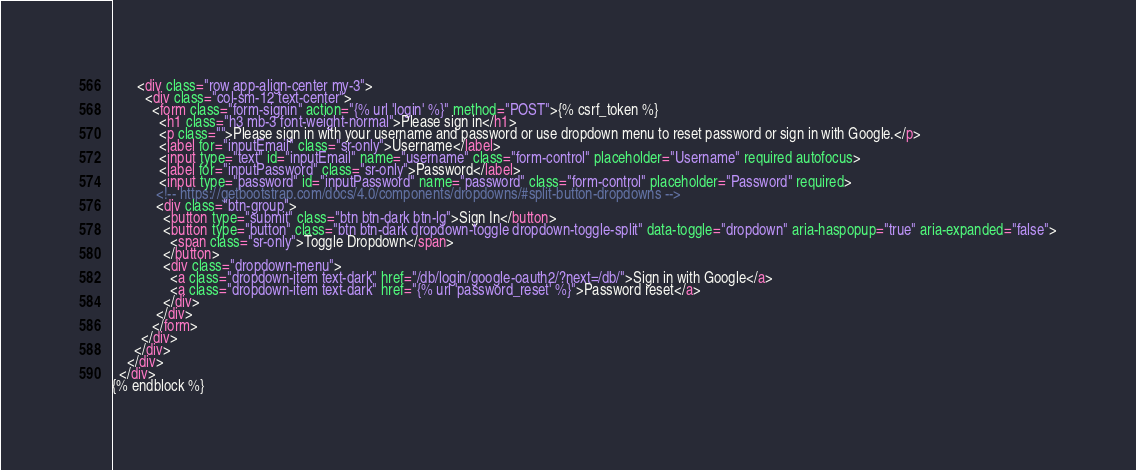<code> <loc_0><loc_0><loc_500><loc_500><_HTML_>       <div class="row app-align-center my-3">
         <div class="col-sm-12 text-center">
           <form class="form-signin" action="{% url 'login' %}" method="POST">{% csrf_token %}
             <h1 class="h3 mb-3 font-weight-normal">Please sign in</h1>
             <p class="">Please sign in with your username and password or use dropdown menu to reset password or sign in with Google.</p>
             <label for="inputEmail" class="sr-only">Username</label>
             <input type="text" id="inputEmail" name="username" class="form-control" placeholder="Username" required autofocus>
             <label for="inputPassword" class="sr-only">Password</label>
             <input type="password" id="inputPassword" name="password" class="form-control" placeholder="Password" required>
            <!-- https://getbootstrap.com/docs/4.0/components/dropdowns/#split-button-dropdowns -->
            <div class="btn-group">
              <button type="submit" class="btn btn-dark btn-lg">Sign In</button>
              <button type="button" class="btn btn-dark dropdown-toggle dropdown-toggle-split" data-toggle="dropdown" aria-haspopup="true" aria-expanded="false">
                <span class="sr-only">Toggle Dropdown</span>
              </button>
              <div class="dropdown-menu">
                <a class="dropdown-item text-dark" href="/db/login/google-oauth2/?next=/db/">Sign in with Google</a>
                <a class="dropdown-item text-dark" href="{% url 'password_reset' %}">Password reset</a>
              </div>
            </div>
           </form>
        </div>
      </div>
    </div>
  </div>
{% endblock %}
</code> 